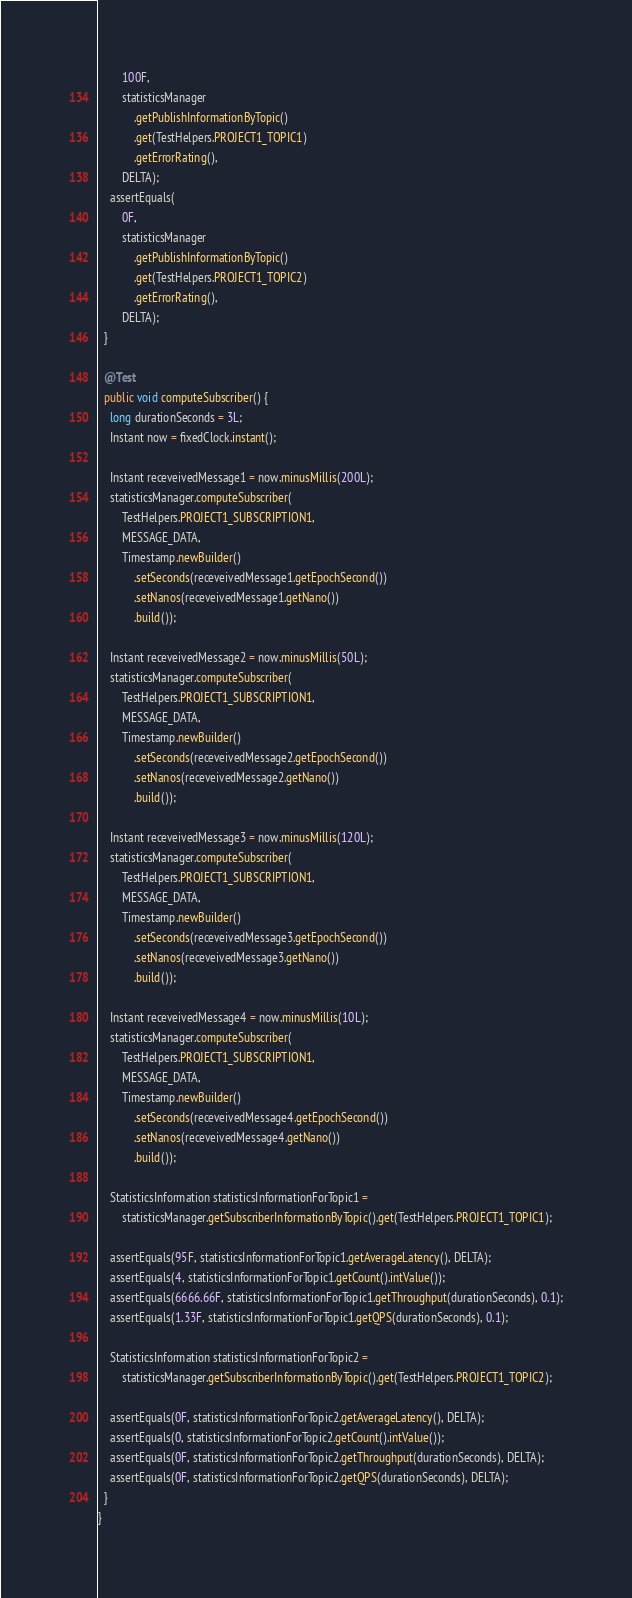Convert code to text. <code><loc_0><loc_0><loc_500><loc_500><_Java_>        100F,
        statisticsManager
            .getPublishInformationByTopic()
            .get(TestHelpers.PROJECT1_TOPIC1)
            .getErrorRating(),
        DELTA);
    assertEquals(
        0F,
        statisticsManager
            .getPublishInformationByTopic()
            .get(TestHelpers.PROJECT1_TOPIC2)
            .getErrorRating(),
        DELTA);
  }

  @Test
  public void computeSubscriber() {
    long durationSeconds = 3L;
    Instant now = fixedClock.instant();

    Instant receveivedMessage1 = now.minusMillis(200L);
    statisticsManager.computeSubscriber(
        TestHelpers.PROJECT1_SUBSCRIPTION1,
        MESSAGE_DATA,
        Timestamp.newBuilder()
            .setSeconds(receveivedMessage1.getEpochSecond())
            .setNanos(receveivedMessage1.getNano())
            .build());

    Instant receveivedMessage2 = now.minusMillis(50L);
    statisticsManager.computeSubscriber(
        TestHelpers.PROJECT1_SUBSCRIPTION1,
        MESSAGE_DATA,
        Timestamp.newBuilder()
            .setSeconds(receveivedMessage2.getEpochSecond())
            .setNanos(receveivedMessage2.getNano())
            .build());

    Instant receveivedMessage3 = now.minusMillis(120L);
    statisticsManager.computeSubscriber(
        TestHelpers.PROJECT1_SUBSCRIPTION1,
        MESSAGE_DATA,
        Timestamp.newBuilder()
            .setSeconds(receveivedMessage3.getEpochSecond())
            .setNanos(receveivedMessage3.getNano())
            .build());

    Instant receveivedMessage4 = now.minusMillis(10L);
    statisticsManager.computeSubscriber(
        TestHelpers.PROJECT1_SUBSCRIPTION1,
        MESSAGE_DATA,
        Timestamp.newBuilder()
            .setSeconds(receveivedMessage4.getEpochSecond())
            .setNanos(receveivedMessage4.getNano())
            .build());

    StatisticsInformation statisticsInformationForTopic1 =
        statisticsManager.getSubscriberInformationByTopic().get(TestHelpers.PROJECT1_TOPIC1);

    assertEquals(95F, statisticsInformationForTopic1.getAverageLatency(), DELTA);
    assertEquals(4, statisticsInformationForTopic1.getCount().intValue());
    assertEquals(6666.66F, statisticsInformationForTopic1.getThroughput(durationSeconds), 0.1);
    assertEquals(1.33F, statisticsInformationForTopic1.getQPS(durationSeconds), 0.1);

    StatisticsInformation statisticsInformationForTopic2 =
        statisticsManager.getSubscriberInformationByTopic().get(TestHelpers.PROJECT1_TOPIC2);

    assertEquals(0F, statisticsInformationForTopic2.getAverageLatency(), DELTA);
    assertEquals(0, statisticsInformationForTopic2.getCount().intValue());
    assertEquals(0F, statisticsInformationForTopic2.getThroughput(durationSeconds), DELTA);
    assertEquals(0F, statisticsInformationForTopic2.getQPS(durationSeconds), DELTA);
  }
}
</code> 